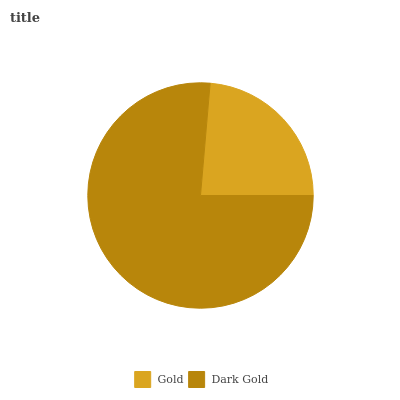Is Gold the minimum?
Answer yes or no. Yes. Is Dark Gold the maximum?
Answer yes or no. Yes. Is Dark Gold the minimum?
Answer yes or no. No. Is Dark Gold greater than Gold?
Answer yes or no. Yes. Is Gold less than Dark Gold?
Answer yes or no. Yes. Is Gold greater than Dark Gold?
Answer yes or no. No. Is Dark Gold less than Gold?
Answer yes or no. No. Is Dark Gold the high median?
Answer yes or no. Yes. Is Gold the low median?
Answer yes or no. Yes. Is Gold the high median?
Answer yes or no. No. Is Dark Gold the low median?
Answer yes or no. No. 